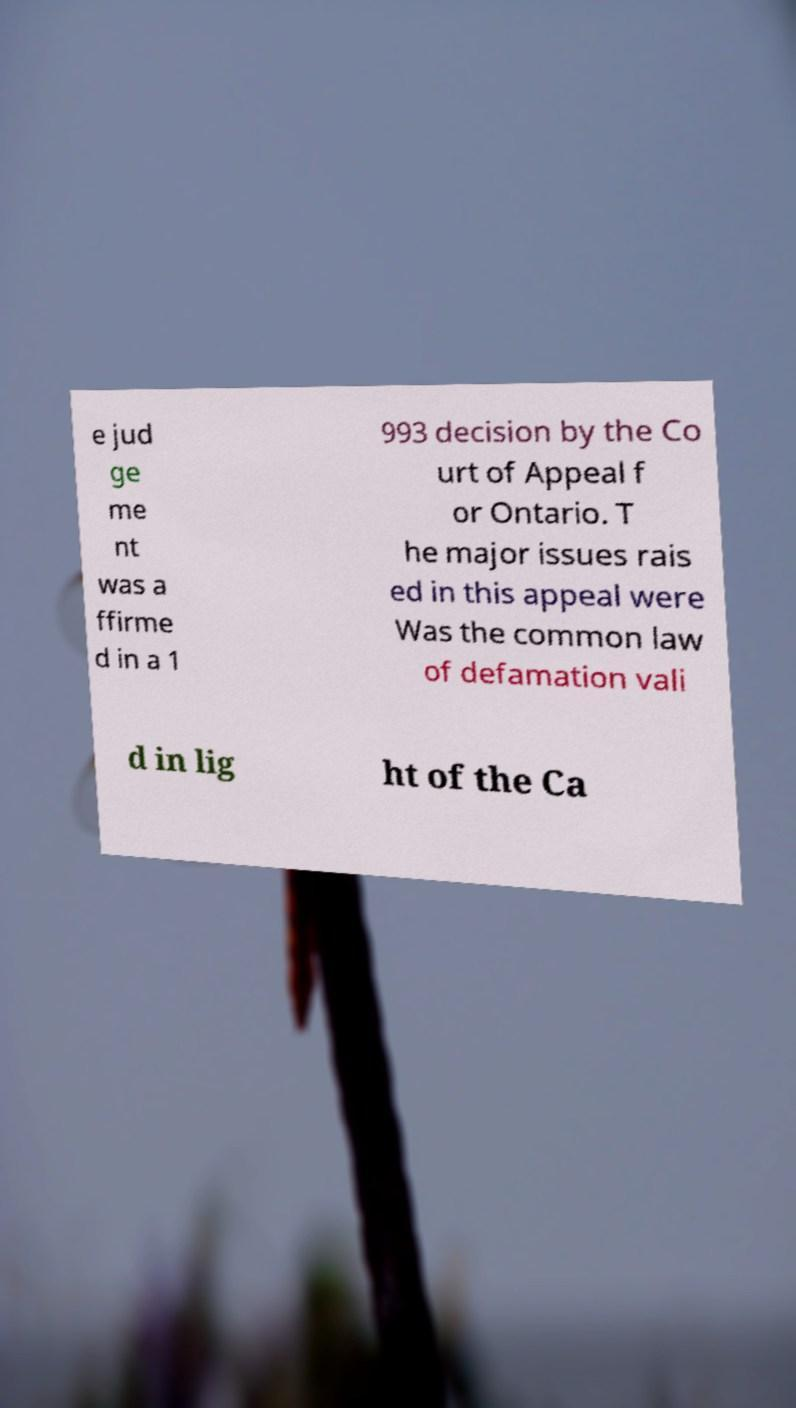I need the written content from this picture converted into text. Can you do that? e jud ge me nt was a ffirme d in a 1 993 decision by the Co urt of Appeal f or Ontario. T he major issues rais ed in this appeal were Was the common law of defamation vali d in lig ht of the Ca 